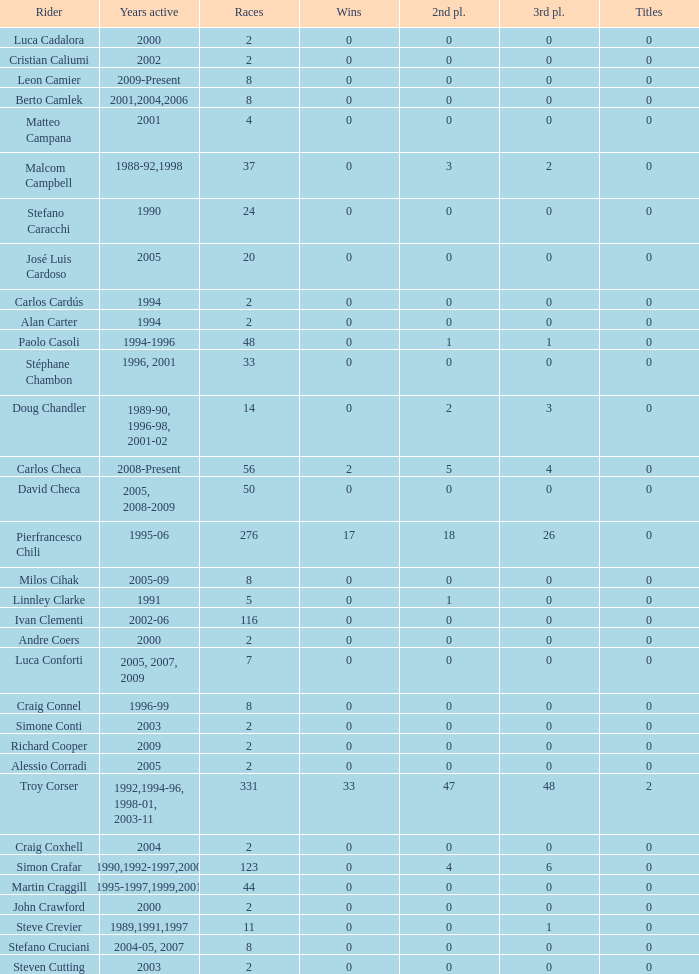What is the total number of wins for riders with fewer than 56 races and more than 0 titles? 0.0. 